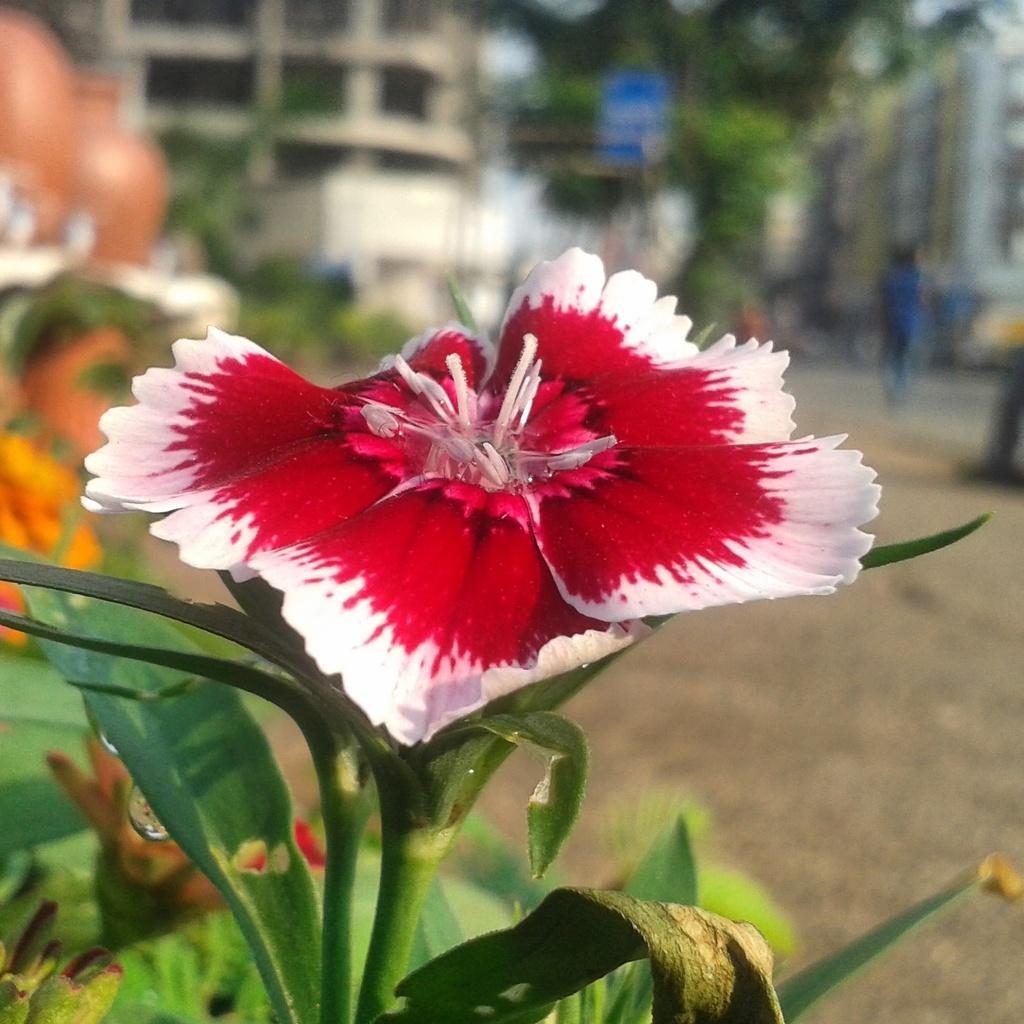Please provide a concise description of this image. In this image I can see the flowers to the plant. I can see the flowers are in red and white color. In the background I can see the person, trees, board and many buildings. But the background is blurred. 